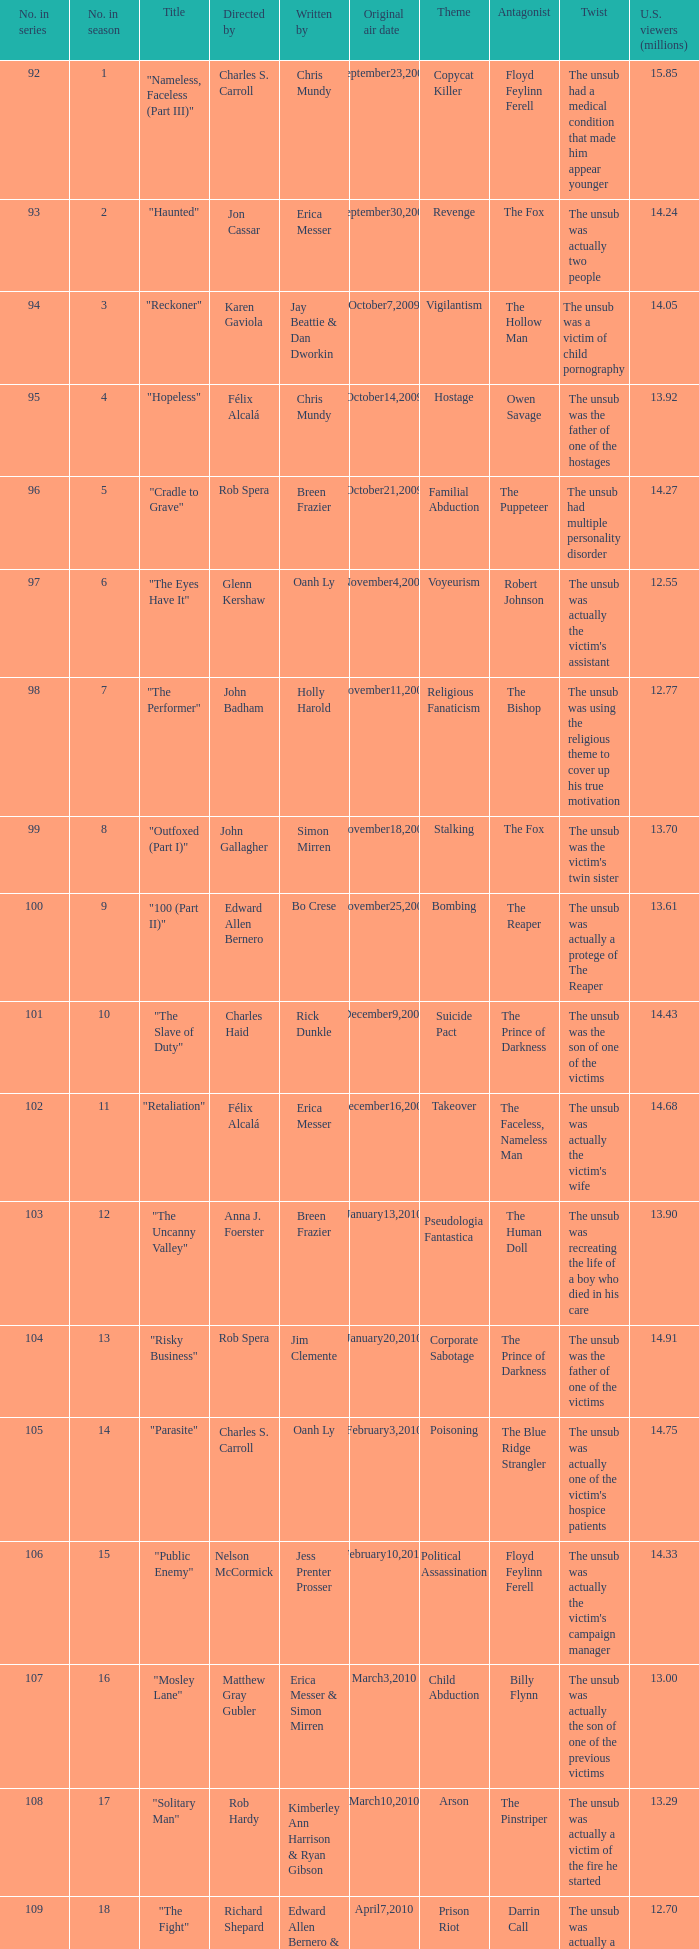What was the first episode in the season directed by nelson mccormick? 15.0. 